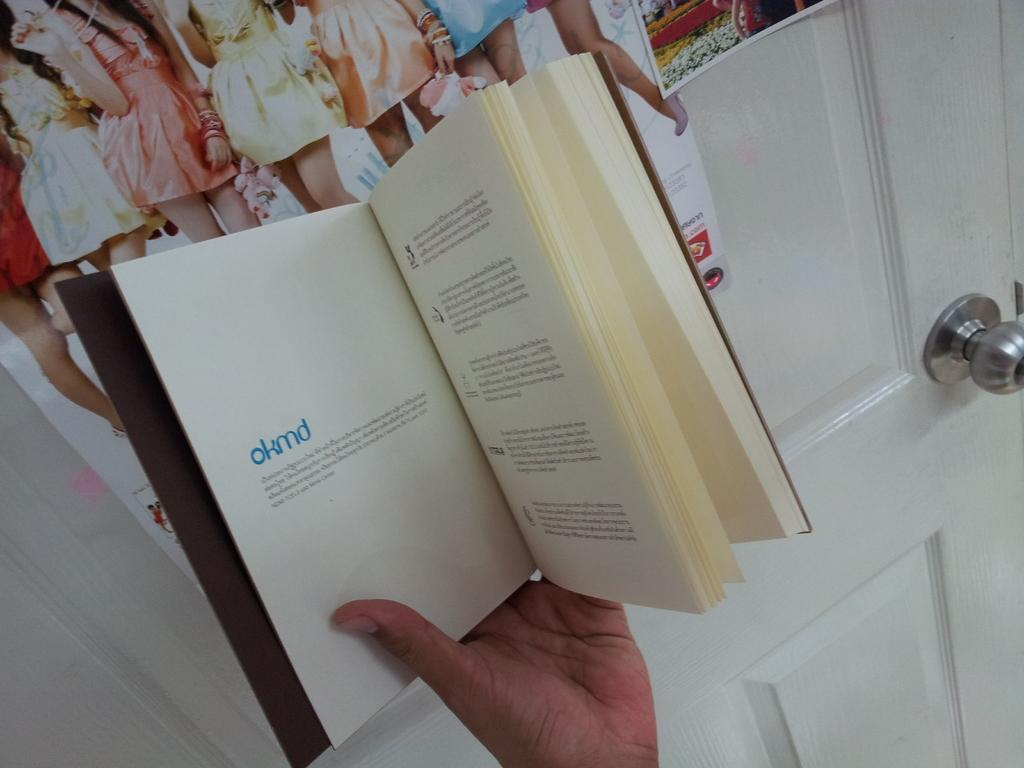<image>
Describe the image concisely. an open book to a page that says okmd in blue 